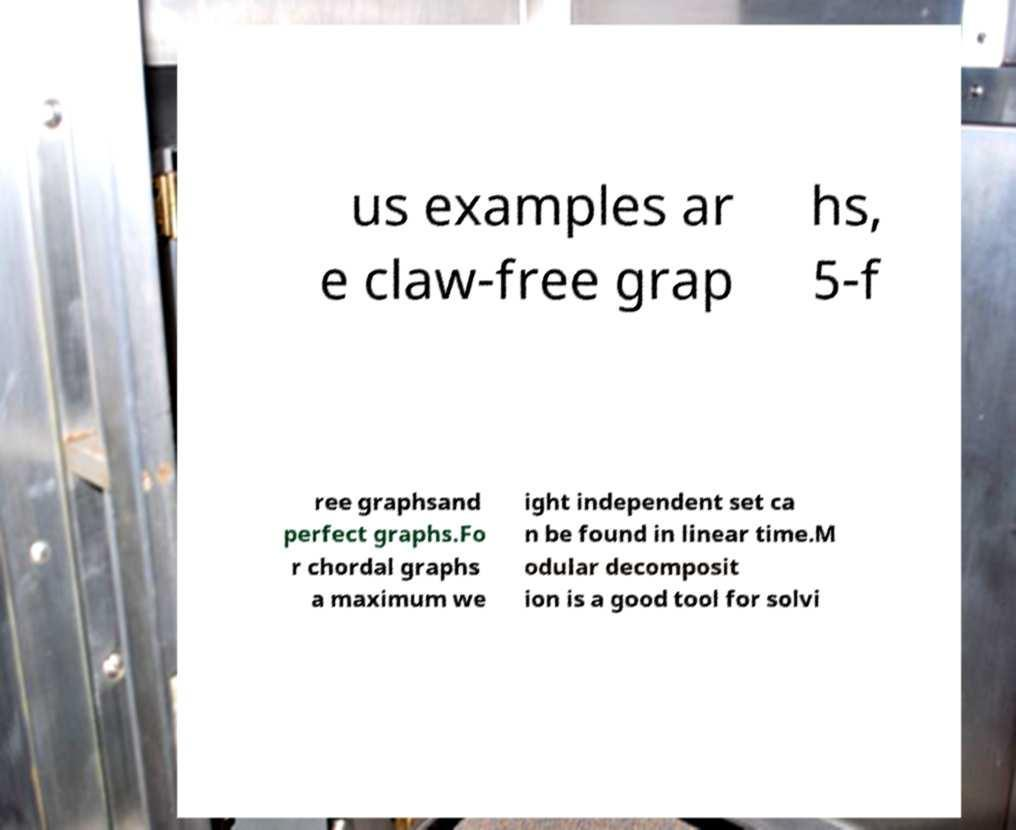For documentation purposes, I need the text within this image transcribed. Could you provide that? us examples ar e claw-free grap hs, 5-f ree graphsand perfect graphs.Fo r chordal graphs a maximum we ight independent set ca n be found in linear time.M odular decomposit ion is a good tool for solvi 